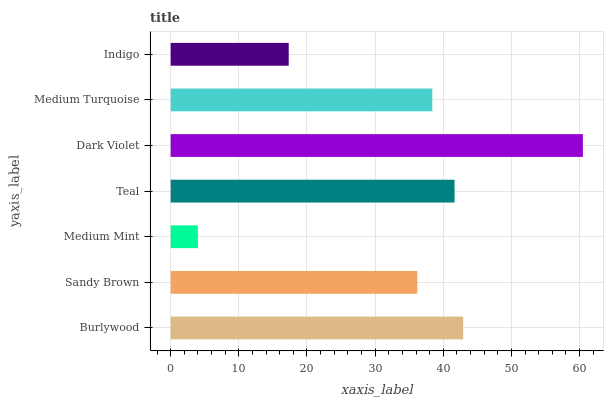Is Medium Mint the minimum?
Answer yes or no. Yes. Is Dark Violet the maximum?
Answer yes or no. Yes. Is Sandy Brown the minimum?
Answer yes or no. No. Is Sandy Brown the maximum?
Answer yes or no. No. Is Burlywood greater than Sandy Brown?
Answer yes or no. Yes. Is Sandy Brown less than Burlywood?
Answer yes or no. Yes. Is Sandy Brown greater than Burlywood?
Answer yes or no. No. Is Burlywood less than Sandy Brown?
Answer yes or no. No. Is Medium Turquoise the high median?
Answer yes or no. Yes. Is Medium Turquoise the low median?
Answer yes or no. Yes. Is Teal the high median?
Answer yes or no. No. Is Medium Mint the low median?
Answer yes or no. No. 